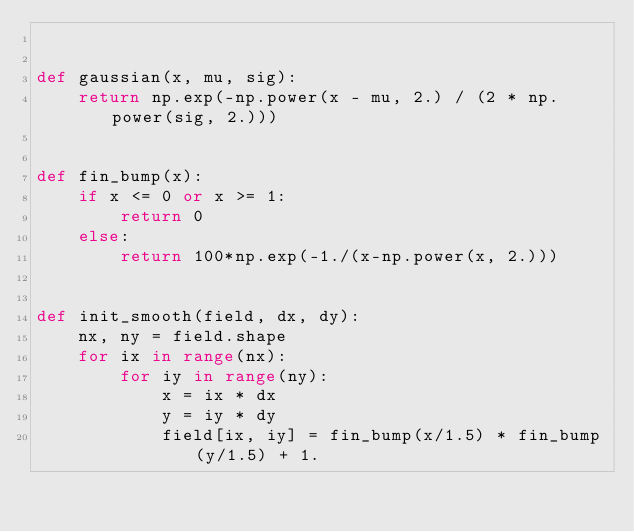<code> <loc_0><loc_0><loc_500><loc_500><_Python_>

def gaussian(x, mu, sig):
    return np.exp(-np.power(x - mu, 2.) / (2 * np.power(sig, 2.)))


def fin_bump(x):
    if x <= 0 or x >= 1:
        return 0
    else:
        return 100*np.exp(-1./(x-np.power(x, 2.)))


def init_smooth(field, dx, dy):
    nx, ny = field.shape
    for ix in range(nx):
        for iy in range(ny):
            x = ix * dx
            y = iy * dy
            field[ix, iy] = fin_bump(x/1.5) * fin_bump(y/1.5) + 1.
</code> 